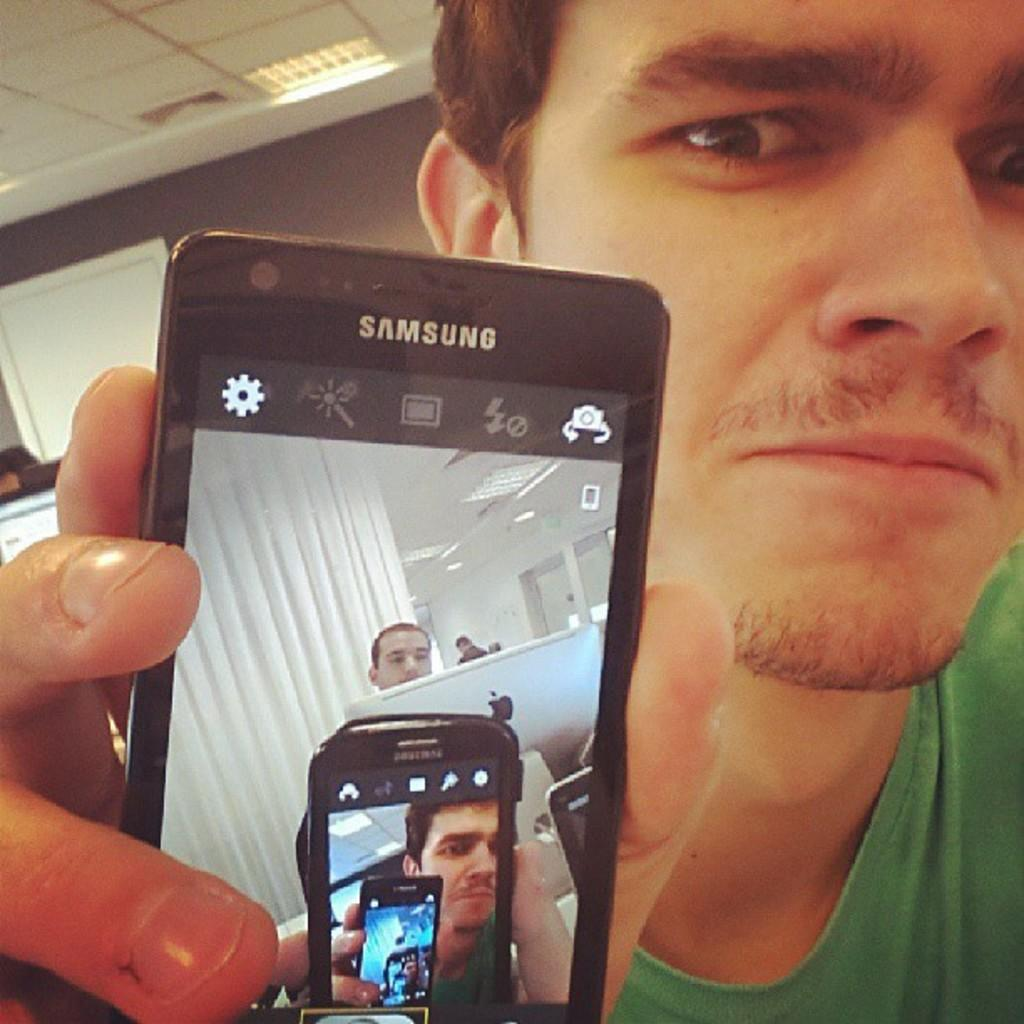Provide a one-sentence caption for the provided image. A man holding up a samsung phone with the camera app open. 